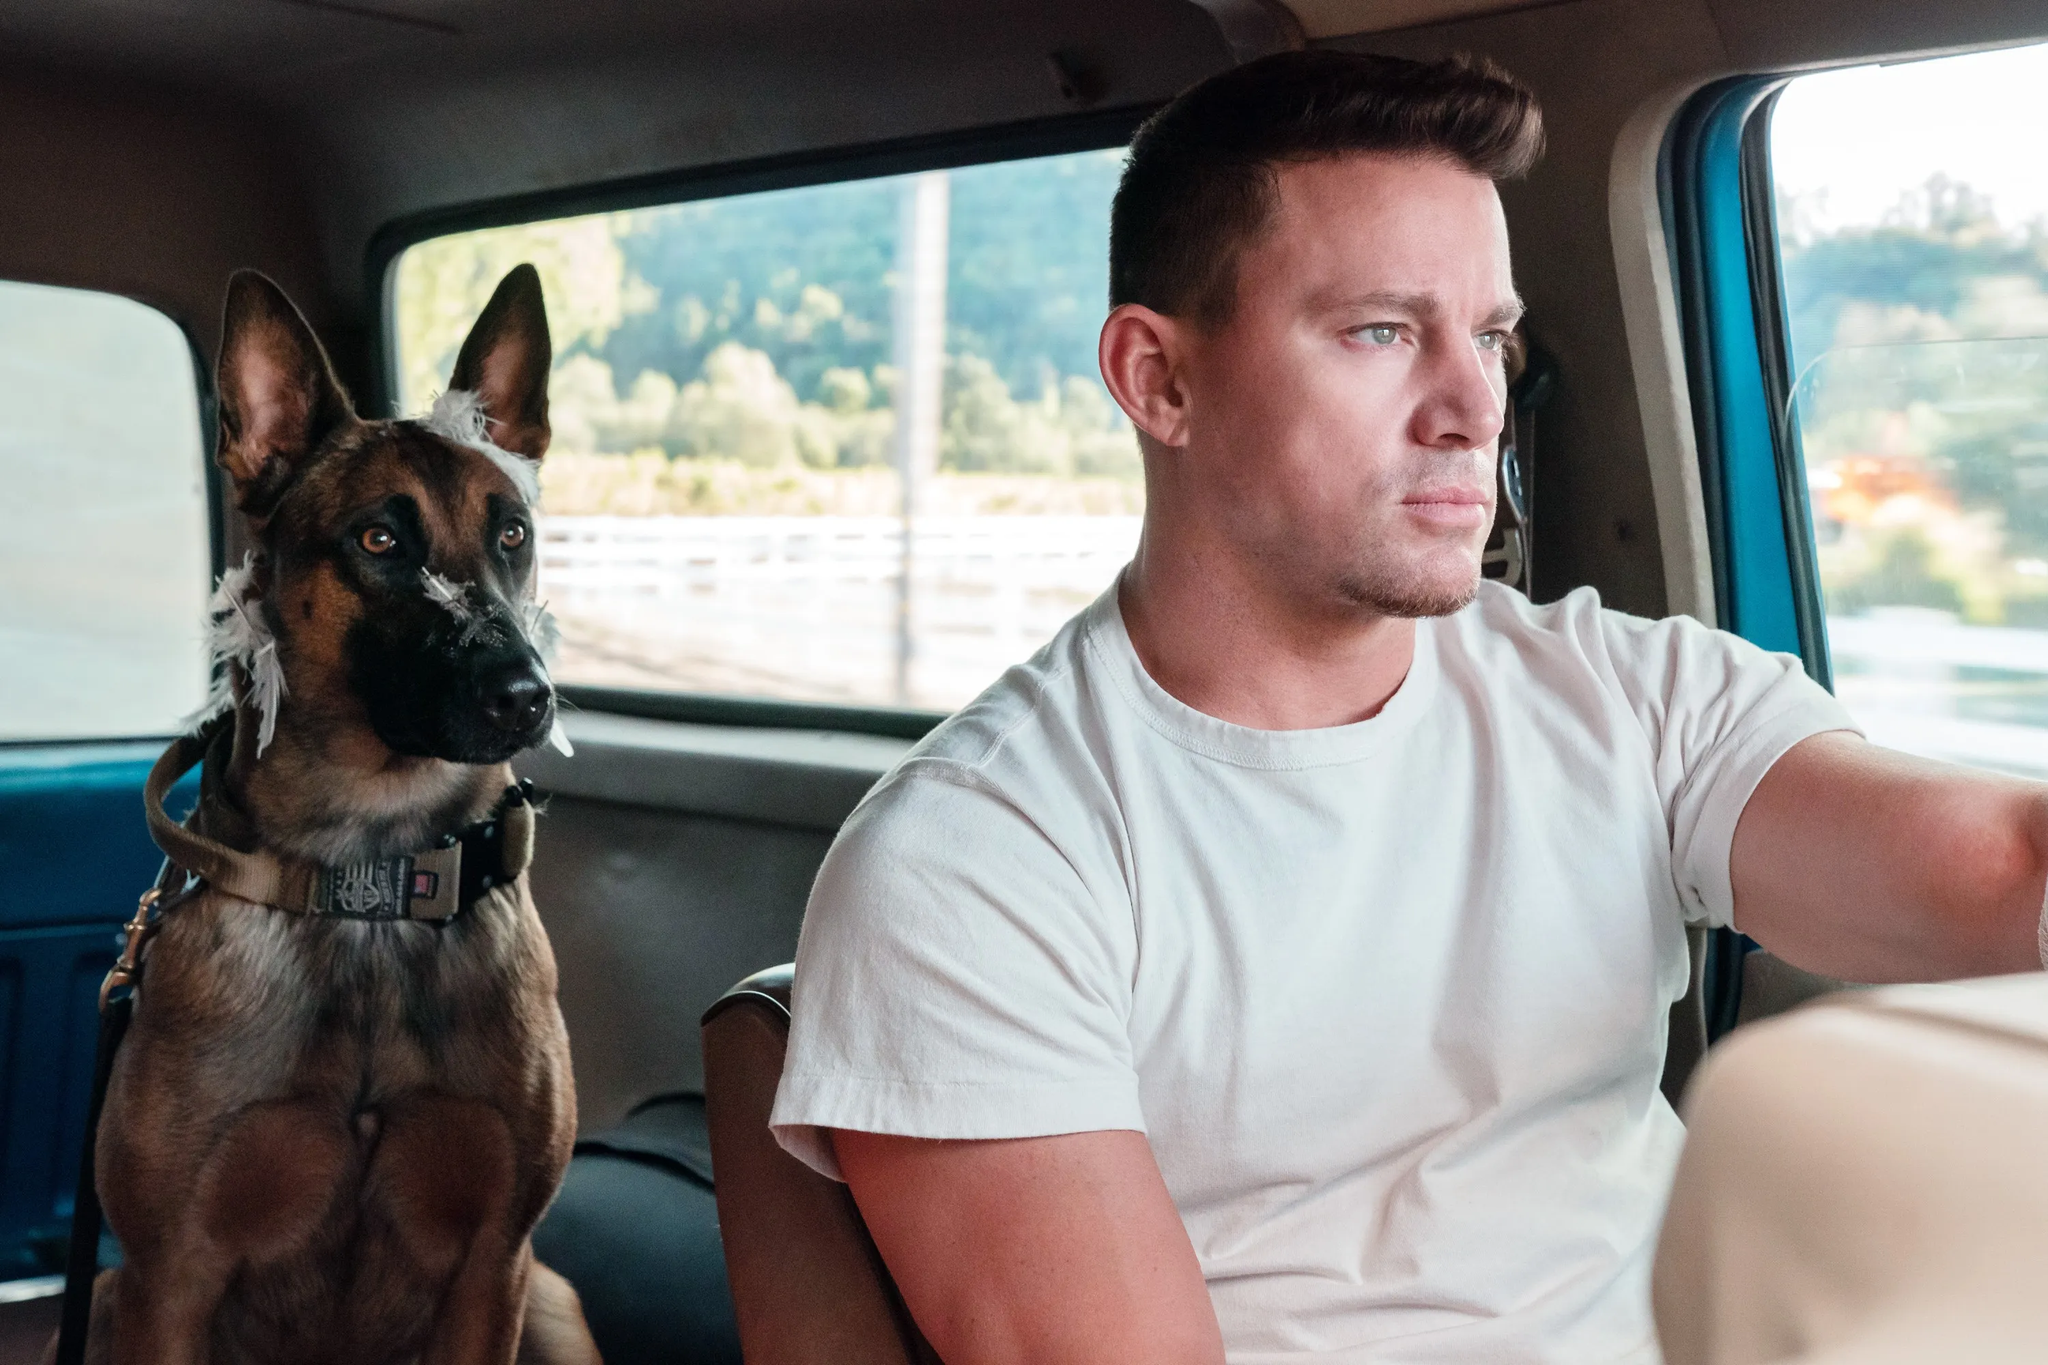How might this image symbolize the bond between humans and their pets? This image beautifully captures the deep bond between humans and their pets. The man and his dog share a tranquil moment during a car ride, illustrating a sense of mutual trust and companionship. The dog's calm demeanor and the man's focused yet relaxed expression suggest a seamless coexistence and understanding between them. This moment of shared journey symbolizes the loyalty, trust, and unspoken connection that often defines the relationship between humans and their pets. 